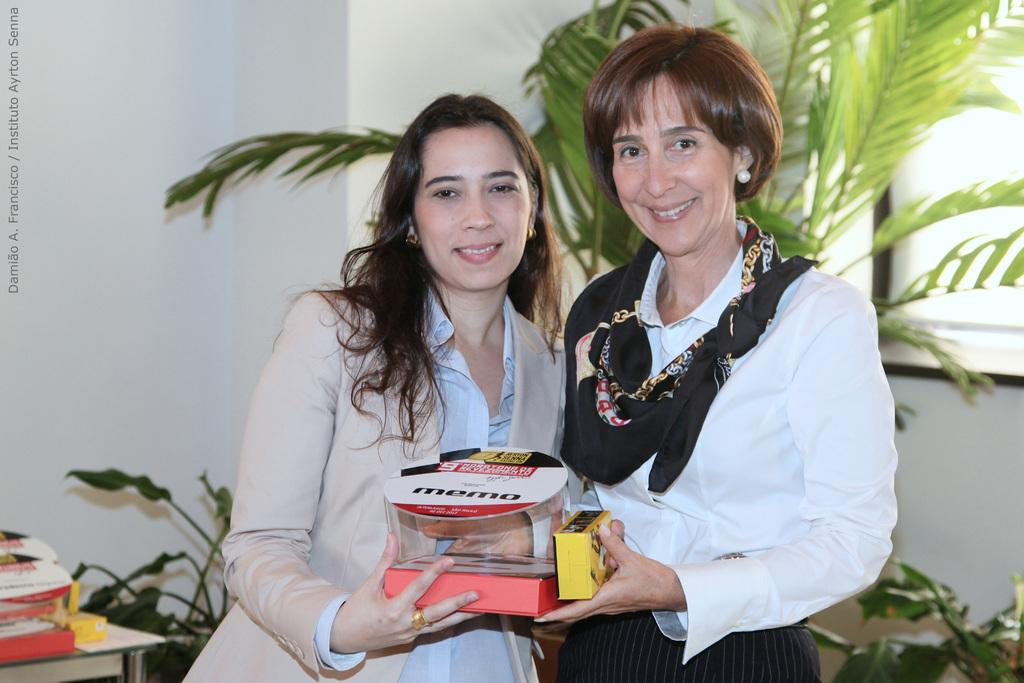How many people are in the image? There are two persons in the image. What are the persons holding in the image? The persons are holding objects. Can you describe the natural elements in the image? There is a tree and plants in the image. What is visible on a surface in the image? There are objects on a table in the image. What architectural feature can be seen in the image? There is a wall in the image. Is there any text present in the image? Yes, there is text on the left side of the image. What type of shirt is the person wearing on the right side of the image? There is no shirt visible in the image, as the persons are holding objects and not wearing any clothing. 